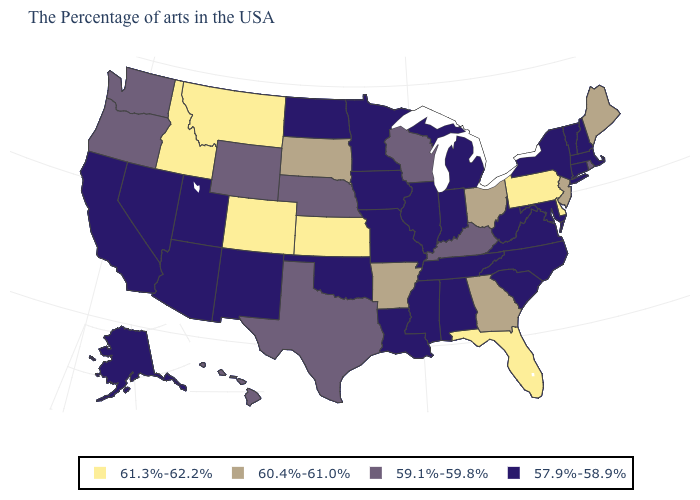What is the highest value in the Northeast ?
Answer briefly. 61.3%-62.2%. What is the value of Arkansas?
Short answer required. 60.4%-61.0%. What is the value of Pennsylvania?
Be succinct. 61.3%-62.2%. Does the map have missing data?
Quick response, please. No. Does Maine have a lower value than North Carolina?
Give a very brief answer. No. What is the value of Ohio?
Keep it brief. 60.4%-61.0%. What is the highest value in the MidWest ?
Be succinct. 61.3%-62.2%. Name the states that have a value in the range 60.4%-61.0%?
Answer briefly. Maine, New Jersey, Ohio, Georgia, Arkansas, South Dakota. Name the states that have a value in the range 57.9%-58.9%?
Answer briefly. Massachusetts, New Hampshire, Vermont, Connecticut, New York, Maryland, Virginia, North Carolina, South Carolina, West Virginia, Michigan, Indiana, Alabama, Tennessee, Illinois, Mississippi, Louisiana, Missouri, Minnesota, Iowa, Oklahoma, North Dakota, New Mexico, Utah, Arizona, Nevada, California, Alaska. Among the states that border Idaho , does Montana have the highest value?
Give a very brief answer. Yes. What is the value of Illinois?
Concise answer only. 57.9%-58.9%. What is the lowest value in the USA?
Short answer required. 57.9%-58.9%. What is the lowest value in states that border Maryland?
Write a very short answer. 57.9%-58.9%. Name the states that have a value in the range 59.1%-59.8%?
Keep it brief. Rhode Island, Kentucky, Wisconsin, Nebraska, Texas, Wyoming, Washington, Oregon, Hawaii. How many symbols are there in the legend?
Quick response, please. 4. 